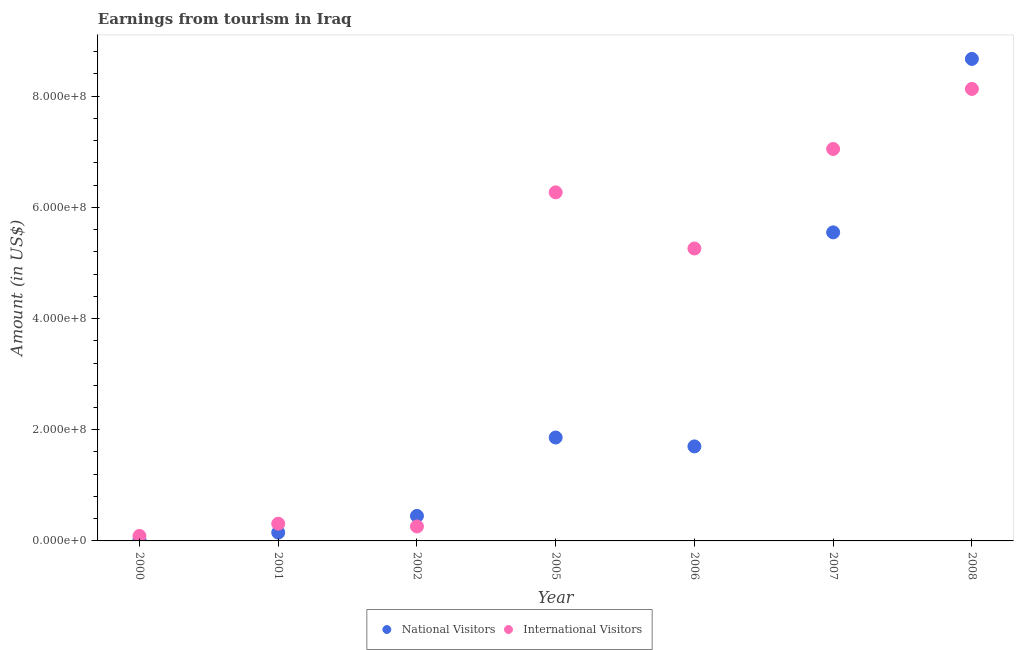How many different coloured dotlines are there?
Offer a terse response. 2. Is the number of dotlines equal to the number of legend labels?
Ensure brevity in your answer.  Yes. What is the amount earned from international visitors in 2008?
Give a very brief answer. 8.13e+08. Across all years, what is the maximum amount earned from national visitors?
Give a very brief answer. 8.67e+08. Across all years, what is the minimum amount earned from national visitors?
Ensure brevity in your answer.  2.00e+06. In which year was the amount earned from international visitors minimum?
Keep it short and to the point. 2000. What is the total amount earned from international visitors in the graph?
Offer a terse response. 2.74e+09. What is the difference between the amount earned from national visitors in 2001 and that in 2005?
Give a very brief answer. -1.71e+08. What is the difference between the amount earned from national visitors in 2007 and the amount earned from international visitors in 2001?
Your answer should be very brief. 5.24e+08. What is the average amount earned from international visitors per year?
Keep it short and to the point. 3.91e+08. In the year 2000, what is the difference between the amount earned from international visitors and amount earned from national visitors?
Provide a short and direct response. 7.00e+06. In how many years, is the amount earned from international visitors greater than 840000000 US$?
Your response must be concise. 0. What is the ratio of the amount earned from national visitors in 2000 to that in 2008?
Give a very brief answer. 0. Is the amount earned from international visitors in 2002 less than that in 2007?
Your response must be concise. Yes. What is the difference between the highest and the second highest amount earned from national visitors?
Offer a very short reply. 3.12e+08. What is the difference between the highest and the lowest amount earned from national visitors?
Provide a short and direct response. 8.65e+08. In how many years, is the amount earned from national visitors greater than the average amount earned from national visitors taken over all years?
Make the answer very short. 2. Is the amount earned from national visitors strictly less than the amount earned from international visitors over the years?
Offer a very short reply. No. How many dotlines are there?
Your answer should be very brief. 2. How many years are there in the graph?
Provide a short and direct response. 7. What is the difference between two consecutive major ticks on the Y-axis?
Your response must be concise. 2.00e+08. Are the values on the major ticks of Y-axis written in scientific E-notation?
Offer a terse response. Yes. Does the graph contain grids?
Your answer should be compact. No. Where does the legend appear in the graph?
Give a very brief answer. Bottom center. How many legend labels are there?
Offer a terse response. 2. How are the legend labels stacked?
Your answer should be compact. Horizontal. What is the title of the graph?
Your response must be concise. Earnings from tourism in Iraq. What is the label or title of the X-axis?
Make the answer very short. Year. What is the label or title of the Y-axis?
Your answer should be compact. Amount (in US$). What is the Amount (in US$) in International Visitors in 2000?
Provide a short and direct response. 9.00e+06. What is the Amount (in US$) in National Visitors in 2001?
Your answer should be very brief. 1.50e+07. What is the Amount (in US$) in International Visitors in 2001?
Provide a short and direct response. 3.10e+07. What is the Amount (in US$) of National Visitors in 2002?
Your answer should be very brief. 4.50e+07. What is the Amount (in US$) in International Visitors in 2002?
Give a very brief answer. 2.60e+07. What is the Amount (in US$) of National Visitors in 2005?
Your answer should be very brief. 1.86e+08. What is the Amount (in US$) in International Visitors in 2005?
Keep it short and to the point. 6.27e+08. What is the Amount (in US$) in National Visitors in 2006?
Your response must be concise. 1.70e+08. What is the Amount (in US$) in International Visitors in 2006?
Your response must be concise. 5.26e+08. What is the Amount (in US$) of National Visitors in 2007?
Your answer should be very brief. 5.55e+08. What is the Amount (in US$) of International Visitors in 2007?
Provide a short and direct response. 7.05e+08. What is the Amount (in US$) of National Visitors in 2008?
Give a very brief answer. 8.67e+08. What is the Amount (in US$) in International Visitors in 2008?
Make the answer very short. 8.13e+08. Across all years, what is the maximum Amount (in US$) in National Visitors?
Keep it short and to the point. 8.67e+08. Across all years, what is the maximum Amount (in US$) of International Visitors?
Your answer should be compact. 8.13e+08. Across all years, what is the minimum Amount (in US$) in National Visitors?
Give a very brief answer. 2.00e+06. Across all years, what is the minimum Amount (in US$) of International Visitors?
Keep it short and to the point. 9.00e+06. What is the total Amount (in US$) in National Visitors in the graph?
Your answer should be very brief. 1.84e+09. What is the total Amount (in US$) in International Visitors in the graph?
Offer a very short reply. 2.74e+09. What is the difference between the Amount (in US$) of National Visitors in 2000 and that in 2001?
Provide a succinct answer. -1.30e+07. What is the difference between the Amount (in US$) of International Visitors in 2000 and that in 2001?
Keep it short and to the point. -2.20e+07. What is the difference between the Amount (in US$) of National Visitors in 2000 and that in 2002?
Give a very brief answer. -4.30e+07. What is the difference between the Amount (in US$) in International Visitors in 2000 and that in 2002?
Offer a very short reply. -1.70e+07. What is the difference between the Amount (in US$) of National Visitors in 2000 and that in 2005?
Offer a very short reply. -1.84e+08. What is the difference between the Amount (in US$) in International Visitors in 2000 and that in 2005?
Provide a short and direct response. -6.18e+08. What is the difference between the Amount (in US$) of National Visitors in 2000 and that in 2006?
Offer a very short reply. -1.68e+08. What is the difference between the Amount (in US$) in International Visitors in 2000 and that in 2006?
Make the answer very short. -5.17e+08. What is the difference between the Amount (in US$) in National Visitors in 2000 and that in 2007?
Offer a terse response. -5.53e+08. What is the difference between the Amount (in US$) of International Visitors in 2000 and that in 2007?
Your answer should be very brief. -6.96e+08. What is the difference between the Amount (in US$) of National Visitors in 2000 and that in 2008?
Offer a terse response. -8.65e+08. What is the difference between the Amount (in US$) in International Visitors in 2000 and that in 2008?
Give a very brief answer. -8.04e+08. What is the difference between the Amount (in US$) in National Visitors in 2001 and that in 2002?
Keep it short and to the point. -3.00e+07. What is the difference between the Amount (in US$) in International Visitors in 2001 and that in 2002?
Make the answer very short. 5.00e+06. What is the difference between the Amount (in US$) of National Visitors in 2001 and that in 2005?
Keep it short and to the point. -1.71e+08. What is the difference between the Amount (in US$) in International Visitors in 2001 and that in 2005?
Ensure brevity in your answer.  -5.96e+08. What is the difference between the Amount (in US$) of National Visitors in 2001 and that in 2006?
Your answer should be very brief. -1.55e+08. What is the difference between the Amount (in US$) in International Visitors in 2001 and that in 2006?
Ensure brevity in your answer.  -4.95e+08. What is the difference between the Amount (in US$) of National Visitors in 2001 and that in 2007?
Keep it short and to the point. -5.40e+08. What is the difference between the Amount (in US$) of International Visitors in 2001 and that in 2007?
Make the answer very short. -6.74e+08. What is the difference between the Amount (in US$) in National Visitors in 2001 and that in 2008?
Your answer should be very brief. -8.52e+08. What is the difference between the Amount (in US$) in International Visitors in 2001 and that in 2008?
Give a very brief answer. -7.82e+08. What is the difference between the Amount (in US$) in National Visitors in 2002 and that in 2005?
Make the answer very short. -1.41e+08. What is the difference between the Amount (in US$) of International Visitors in 2002 and that in 2005?
Provide a succinct answer. -6.01e+08. What is the difference between the Amount (in US$) of National Visitors in 2002 and that in 2006?
Your response must be concise. -1.25e+08. What is the difference between the Amount (in US$) in International Visitors in 2002 and that in 2006?
Offer a very short reply. -5.00e+08. What is the difference between the Amount (in US$) of National Visitors in 2002 and that in 2007?
Your answer should be very brief. -5.10e+08. What is the difference between the Amount (in US$) in International Visitors in 2002 and that in 2007?
Make the answer very short. -6.79e+08. What is the difference between the Amount (in US$) of National Visitors in 2002 and that in 2008?
Provide a short and direct response. -8.22e+08. What is the difference between the Amount (in US$) in International Visitors in 2002 and that in 2008?
Ensure brevity in your answer.  -7.87e+08. What is the difference between the Amount (in US$) of National Visitors in 2005 and that in 2006?
Your response must be concise. 1.60e+07. What is the difference between the Amount (in US$) of International Visitors in 2005 and that in 2006?
Your answer should be compact. 1.01e+08. What is the difference between the Amount (in US$) of National Visitors in 2005 and that in 2007?
Keep it short and to the point. -3.69e+08. What is the difference between the Amount (in US$) of International Visitors in 2005 and that in 2007?
Your answer should be compact. -7.80e+07. What is the difference between the Amount (in US$) of National Visitors in 2005 and that in 2008?
Your answer should be compact. -6.81e+08. What is the difference between the Amount (in US$) in International Visitors in 2005 and that in 2008?
Give a very brief answer. -1.86e+08. What is the difference between the Amount (in US$) in National Visitors in 2006 and that in 2007?
Provide a short and direct response. -3.85e+08. What is the difference between the Amount (in US$) in International Visitors in 2006 and that in 2007?
Your answer should be very brief. -1.79e+08. What is the difference between the Amount (in US$) in National Visitors in 2006 and that in 2008?
Provide a short and direct response. -6.97e+08. What is the difference between the Amount (in US$) of International Visitors in 2006 and that in 2008?
Your answer should be very brief. -2.87e+08. What is the difference between the Amount (in US$) of National Visitors in 2007 and that in 2008?
Give a very brief answer. -3.12e+08. What is the difference between the Amount (in US$) in International Visitors in 2007 and that in 2008?
Make the answer very short. -1.08e+08. What is the difference between the Amount (in US$) in National Visitors in 2000 and the Amount (in US$) in International Visitors in 2001?
Keep it short and to the point. -2.90e+07. What is the difference between the Amount (in US$) of National Visitors in 2000 and the Amount (in US$) of International Visitors in 2002?
Offer a terse response. -2.40e+07. What is the difference between the Amount (in US$) in National Visitors in 2000 and the Amount (in US$) in International Visitors in 2005?
Your response must be concise. -6.25e+08. What is the difference between the Amount (in US$) in National Visitors in 2000 and the Amount (in US$) in International Visitors in 2006?
Provide a succinct answer. -5.24e+08. What is the difference between the Amount (in US$) of National Visitors in 2000 and the Amount (in US$) of International Visitors in 2007?
Keep it short and to the point. -7.03e+08. What is the difference between the Amount (in US$) of National Visitors in 2000 and the Amount (in US$) of International Visitors in 2008?
Provide a short and direct response. -8.11e+08. What is the difference between the Amount (in US$) of National Visitors in 2001 and the Amount (in US$) of International Visitors in 2002?
Make the answer very short. -1.10e+07. What is the difference between the Amount (in US$) of National Visitors in 2001 and the Amount (in US$) of International Visitors in 2005?
Your answer should be compact. -6.12e+08. What is the difference between the Amount (in US$) in National Visitors in 2001 and the Amount (in US$) in International Visitors in 2006?
Your answer should be very brief. -5.11e+08. What is the difference between the Amount (in US$) in National Visitors in 2001 and the Amount (in US$) in International Visitors in 2007?
Ensure brevity in your answer.  -6.90e+08. What is the difference between the Amount (in US$) in National Visitors in 2001 and the Amount (in US$) in International Visitors in 2008?
Your answer should be compact. -7.98e+08. What is the difference between the Amount (in US$) in National Visitors in 2002 and the Amount (in US$) in International Visitors in 2005?
Make the answer very short. -5.82e+08. What is the difference between the Amount (in US$) of National Visitors in 2002 and the Amount (in US$) of International Visitors in 2006?
Give a very brief answer. -4.81e+08. What is the difference between the Amount (in US$) in National Visitors in 2002 and the Amount (in US$) in International Visitors in 2007?
Your answer should be compact. -6.60e+08. What is the difference between the Amount (in US$) of National Visitors in 2002 and the Amount (in US$) of International Visitors in 2008?
Ensure brevity in your answer.  -7.68e+08. What is the difference between the Amount (in US$) of National Visitors in 2005 and the Amount (in US$) of International Visitors in 2006?
Make the answer very short. -3.40e+08. What is the difference between the Amount (in US$) in National Visitors in 2005 and the Amount (in US$) in International Visitors in 2007?
Provide a short and direct response. -5.19e+08. What is the difference between the Amount (in US$) in National Visitors in 2005 and the Amount (in US$) in International Visitors in 2008?
Offer a terse response. -6.27e+08. What is the difference between the Amount (in US$) of National Visitors in 2006 and the Amount (in US$) of International Visitors in 2007?
Ensure brevity in your answer.  -5.35e+08. What is the difference between the Amount (in US$) of National Visitors in 2006 and the Amount (in US$) of International Visitors in 2008?
Your answer should be compact. -6.43e+08. What is the difference between the Amount (in US$) of National Visitors in 2007 and the Amount (in US$) of International Visitors in 2008?
Give a very brief answer. -2.58e+08. What is the average Amount (in US$) of National Visitors per year?
Your answer should be compact. 2.63e+08. What is the average Amount (in US$) in International Visitors per year?
Your answer should be very brief. 3.91e+08. In the year 2000, what is the difference between the Amount (in US$) of National Visitors and Amount (in US$) of International Visitors?
Ensure brevity in your answer.  -7.00e+06. In the year 2001, what is the difference between the Amount (in US$) in National Visitors and Amount (in US$) in International Visitors?
Ensure brevity in your answer.  -1.60e+07. In the year 2002, what is the difference between the Amount (in US$) in National Visitors and Amount (in US$) in International Visitors?
Make the answer very short. 1.90e+07. In the year 2005, what is the difference between the Amount (in US$) of National Visitors and Amount (in US$) of International Visitors?
Make the answer very short. -4.41e+08. In the year 2006, what is the difference between the Amount (in US$) of National Visitors and Amount (in US$) of International Visitors?
Your answer should be compact. -3.56e+08. In the year 2007, what is the difference between the Amount (in US$) of National Visitors and Amount (in US$) of International Visitors?
Make the answer very short. -1.50e+08. In the year 2008, what is the difference between the Amount (in US$) in National Visitors and Amount (in US$) in International Visitors?
Provide a succinct answer. 5.40e+07. What is the ratio of the Amount (in US$) in National Visitors in 2000 to that in 2001?
Your answer should be compact. 0.13. What is the ratio of the Amount (in US$) of International Visitors in 2000 to that in 2001?
Give a very brief answer. 0.29. What is the ratio of the Amount (in US$) of National Visitors in 2000 to that in 2002?
Offer a very short reply. 0.04. What is the ratio of the Amount (in US$) in International Visitors in 2000 to that in 2002?
Offer a terse response. 0.35. What is the ratio of the Amount (in US$) of National Visitors in 2000 to that in 2005?
Give a very brief answer. 0.01. What is the ratio of the Amount (in US$) in International Visitors in 2000 to that in 2005?
Offer a terse response. 0.01. What is the ratio of the Amount (in US$) of National Visitors in 2000 to that in 2006?
Your answer should be compact. 0.01. What is the ratio of the Amount (in US$) of International Visitors in 2000 to that in 2006?
Offer a very short reply. 0.02. What is the ratio of the Amount (in US$) in National Visitors in 2000 to that in 2007?
Make the answer very short. 0. What is the ratio of the Amount (in US$) of International Visitors in 2000 to that in 2007?
Your answer should be very brief. 0.01. What is the ratio of the Amount (in US$) in National Visitors in 2000 to that in 2008?
Provide a succinct answer. 0. What is the ratio of the Amount (in US$) of International Visitors in 2000 to that in 2008?
Your answer should be compact. 0.01. What is the ratio of the Amount (in US$) of International Visitors in 2001 to that in 2002?
Offer a terse response. 1.19. What is the ratio of the Amount (in US$) in National Visitors in 2001 to that in 2005?
Keep it short and to the point. 0.08. What is the ratio of the Amount (in US$) of International Visitors in 2001 to that in 2005?
Keep it short and to the point. 0.05. What is the ratio of the Amount (in US$) of National Visitors in 2001 to that in 2006?
Ensure brevity in your answer.  0.09. What is the ratio of the Amount (in US$) in International Visitors in 2001 to that in 2006?
Provide a short and direct response. 0.06. What is the ratio of the Amount (in US$) of National Visitors in 2001 to that in 2007?
Give a very brief answer. 0.03. What is the ratio of the Amount (in US$) in International Visitors in 2001 to that in 2007?
Your answer should be very brief. 0.04. What is the ratio of the Amount (in US$) in National Visitors in 2001 to that in 2008?
Provide a succinct answer. 0.02. What is the ratio of the Amount (in US$) of International Visitors in 2001 to that in 2008?
Your answer should be compact. 0.04. What is the ratio of the Amount (in US$) in National Visitors in 2002 to that in 2005?
Offer a terse response. 0.24. What is the ratio of the Amount (in US$) of International Visitors in 2002 to that in 2005?
Offer a terse response. 0.04. What is the ratio of the Amount (in US$) in National Visitors in 2002 to that in 2006?
Give a very brief answer. 0.26. What is the ratio of the Amount (in US$) of International Visitors in 2002 to that in 2006?
Your answer should be very brief. 0.05. What is the ratio of the Amount (in US$) of National Visitors in 2002 to that in 2007?
Provide a succinct answer. 0.08. What is the ratio of the Amount (in US$) in International Visitors in 2002 to that in 2007?
Your answer should be compact. 0.04. What is the ratio of the Amount (in US$) of National Visitors in 2002 to that in 2008?
Ensure brevity in your answer.  0.05. What is the ratio of the Amount (in US$) in International Visitors in 2002 to that in 2008?
Offer a very short reply. 0.03. What is the ratio of the Amount (in US$) of National Visitors in 2005 to that in 2006?
Your answer should be compact. 1.09. What is the ratio of the Amount (in US$) in International Visitors in 2005 to that in 2006?
Provide a succinct answer. 1.19. What is the ratio of the Amount (in US$) in National Visitors in 2005 to that in 2007?
Ensure brevity in your answer.  0.34. What is the ratio of the Amount (in US$) of International Visitors in 2005 to that in 2007?
Offer a very short reply. 0.89. What is the ratio of the Amount (in US$) of National Visitors in 2005 to that in 2008?
Your response must be concise. 0.21. What is the ratio of the Amount (in US$) in International Visitors in 2005 to that in 2008?
Ensure brevity in your answer.  0.77. What is the ratio of the Amount (in US$) of National Visitors in 2006 to that in 2007?
Provide a short and direct response. 0.31. What is the ratio of the Amount (in US$) in International Visitors in 2006 to that in 2007?
Ensure brevity in your answer.  0.75. What is the ratio of the Amount (in US$) of National Visitors in 2006 to that in 2008?
Offer a very short reply. 0.2. What is the ratio of the Amount (in US$) in International Visitors in 2006 to that in 2008?
Your response must be concise. 0.65. What is the ratio of the Amount (in US$) in National Visitors in 2007 to that in 2008?
Provide a succinct answer. 0.64. What is the ratio of the Amount (in US$) in International Visitors in 2007 to that in 2008?
Offer a terse response. 0.87. What is the difference between the highest and the second highest Amount (in US$) in National Visitors?
Give a very brief answer. 3.12e+08. What is the difference between the highest and the second highest Amount (in US$) of International Visitors?
Your response must be concise. 1.08e+08. What is the difference between the highest and the lowest Amount (in US$) of National Visitors?
Your answer should be very brief. 8.65e+08. What is the difference between the highest and the lowest Amount (in US$) in International Visitors?
Give a very brief answer. 8.04e+08. 